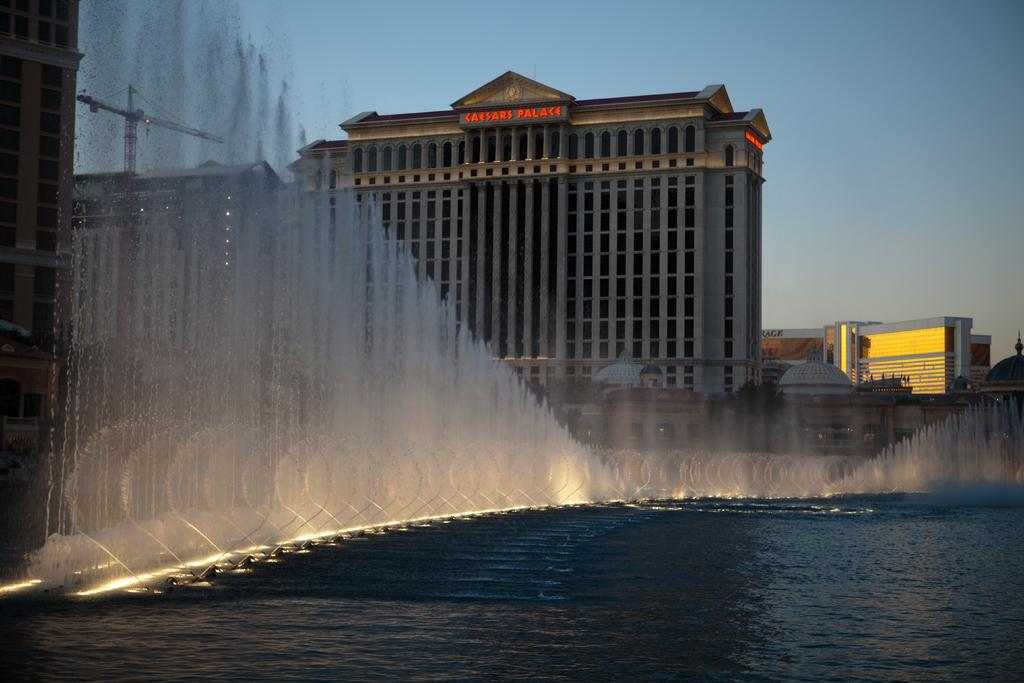What is the primary element visible in the image? There is water in the image. What type of structures can be seen in the image? There are buildings in the image. Can you describe any other objects present in the image? Yes, there are some objects in the image. What can be seen in the background of the image? The sky is visible in the background of the image. What type of protest is taking place near the water in the image? There is no protest present in the image; it only features water, buildings, and other objects. Can you tell me how many people are in jail in the image? There is no jail or any indication of incarceration in the image. 